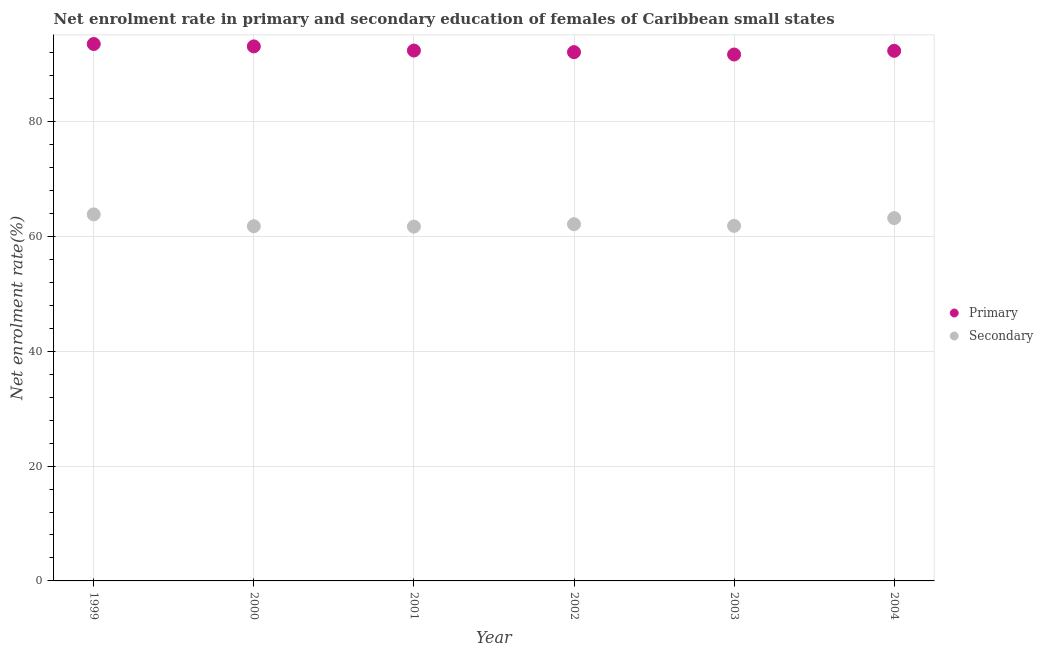What is the enrollment rate in primary education in 2001?
Make the answer very short. 92.38. Across all years, what is the maximum enrollment rate in primary education?
Your response must be concise. 93.51. Across all years, what is the minimum enrollment rate in secondary education?
Keep it short and to the point. 61.71. In which year was the enrollment rate in primary education maximum?
Ensure brevity in your answer.  1999. What is the total enrollment rate in secondary education in the graph?
Provide a succinct answer. 374.48. What is the difference between the enrollment rate in primary education in 2001 and that in 2004?
Give a very brief answer. 0.05. What is the difference between the enrollment rate in secondary education in 2001 and the enrollment rate in primary education in 2002?
Give a very brief answer. -30.38. What is the average enrollment rate in primary education per year?
Provide a succinct answer. 92.52. In the year 2003, what is the difference between the enrollment rate in secondary education and enrollment rate in primary education?
Offer a very short reply. -29.84. What is the ratio of the enrollment rate in secondary education in 2000 to that in 2004?
Keep it short and to the point. 0.98. Is the enrollment rate in secondary education in 1999 less than that in 2001?
Keep it short and to the point. No. Is the difference between the enrollment rate in secondary education in 1999 and 2003 greater than the difference between the enrollment rate in primary education in 1999 and 2003?
Make the answer very short. Yes. What is the difference between the highest and the second highest enrollment rate in primary education?
Your answer should be compact. 0.42. What is the difference between the highest and the lowest enrollment rate in secondary education?
Offer a terse response. 2.12. Is the sum of the enrollment rate in primary education in 1999 and 2001 greater than the maximum enrollment rate in secondary education across all years?
Ensure brevity in your answer.  Yes. Does the enrollment rate in secondary education monotonically increase over the years?
Your answer should be compact. No. What is the title of the graph?
Make the answer very short. Net enrolment rate in primary and secondary education of females of Caribbean small states. What is the label or title of the X-axis?
Ensure brevity in your answer.  Year. What is the label or title of the Y-axis?
Give a very brief answer. Net enrolment rate(%). What is the Net enrolment rate(%) of Primary in 1999?
Make the answer very short. 93.51. What is the Net enrolment rate(%) of Secondary in 1999?
Your answer should be compact. 63.84. What is the Net enrolment rate(%) of Primary in 2000?
Your response must be concise. 93.1. What is the Net enrolment rate(%) in Secondary in 2000?
Offer a very short reply. 61.78. What is the Net enrolment rate(%) in Primary in 2001?
Provide a short and direct response. 92.38. What is the Net enrolment rate(%) of Secondary in 2001?
Your answer should be very brief. 61.71. What is the Net enrolment rate(%) of Primary in 2002?
Make the answer very short. 92.09. What is the Net enrolment rate(%) in Secondary in 2002?
Your answer should be compact. 62.13. What is the Net enrolment rate(%) in Primary in 2003?
Your answer should be very brief. 91.69. What is the Net enrolment rate(%) in Secondary in 2003?
Your response must be concise. 61.84. What is the Net enrolment rate(%) in Primary in 2004?
Your answer should be compact. 92.33. What is the Net enrolment rate(%) in Secondary in 2004?
Offer a terse response. 63.19. Across all years, what is the maximum Net enrolment rate(%) in Primary?
Provide a succinct answer. 93.51. Across all years, what is the maximum Net enrolment rate(%) of Secondary?
Your response must be concise. 63.84. Across all years, what is the minimum Net enrolment rate(%) of Primary?
Your answer should be very brief. 91.69. Across all years, what is the minimum Net enrolment rate(%) of Secondary?
Ensure brevity in your answer.  61.71. What is the total Net enrolment rate(%) of Primary in the graph?
Your answer should be compact. 555.09. What is the total Net enrolment rate(%) in Secondary in the graph?
Make the answer very short. 374.48. What is the difference between the Net enrolment rate(%) of Primary in 1999 and that in 2000?
Make the answer very short. 0.42. What is the difference between the Net enrolment rate(%) in Secondary in 1999 and that in 2000?
Your response must be concise. 2.06. What is the difference between the Net enrolment rate(%) of Primary in 1999 and that in 2001?
Provide a succinct answer. 1.14. What is the difference between the Net enrolment rate(%) of Secondary in 1999 and that in 2001?
Provide a short and direct response. 2.12. What is the difference between the Net enrolment rate(%) of Primary in 1999 and that in 2002?
Your response must be concise. 1.42. What is the difference between the Net enrolment rate(%) in Secondary in 1999 and that in 2002?
Your response must be concise. 1.71. What is the difference between the Net enrolment rate(%) in Primary in 1999 and that in 2003?
Provide a succinct answer. 1.83. What is the difference between the Net enrolment rate(%) of Secondary in 1999 and that in 2003?
Your answer should be very brief. 1.99. What is the difference between the Net enrolment rate(%) in Primary in 1999 and that in 2004?
Offer a terse response. 1.19. What is the difference between the Net enrolment rate(%) of Secondary in 1999 and that in 2004?
Make the answer very short. 0.65. What is the difference between the Net enrolment rate(%) of Primary in 2000 and that in 2001?
Offer a very short reply. 0.72. What is the difference between the Net enrolment rate(%) in Secondary in 2000 and that in 2001?
Keep it short and to the point. 0.06. What is the difference between the Net enrolment rate(%) of Primary in 2000 and that in 2002?
Offer a terse response. 1. What is the difference between the Net enrolment rate(%) in Secondary in 2000 and that in 2002?
Provide a short and direct response. -0.35. What is the difference between the Net enrolment rate(%) in Primary in 2000 and that in 2003?
Ensure brevity in your answer.  1.41. What is the difference between the Net enrolment rate(%) in Secondary in 2000 and that in 2003?
Give a very brief answer. -0.07. What is the difference between the Net enrolment rate(%) in Primary in 2000 and that in 2004?
Offer a terse response. 0.77. What is the difference between the Net enrolment rate(%) of Secondary in 2000 and that in 2004?
Your response must be concise. -1.41. What is the difference between the Net enrolment rate(%) in Primary in 2001 and that in 2002?
Your response must be concise. 0.28. What is the difference between the Net enrolment rate(%) in Secondary in 2001 and that in 2002?
Your response must be concise. -0.42. What is the difference between the Net enrolment rate(%) of Primary in 2001 and that in 2003?
Your answer should be compact. 0.69. What is the difference between the Net enrolment rate(%) in Secondary in 2001 and that in 2003?
Ensure brevity in your answer.  -0.13. What is the difference between the Net enrolment rate(%) of Primary in 2001 and that in 2004?
Offer a terse response. 0.05. What is the difference between the Net enrolment rate(%) of Secondary in 2001 and that in 2004?
Make the answer very short. -1.48. What is the difference between the Net enrolment rate(%) in Primary in 2002 and that in 2003?
Keep it short and to the point. 0.41. What is the difference between the Net enrolment rate(%) in Secondary in 2002 and that in 2003?
Keep it short and to the point. 0.28. What is the difference between the Net enrolment rate(%) in Primary in 2002 and that in 2004?
Provide a succinct answer. -0.23. What is the difference between the Net enrolment rate(%) of Secondary in 2002 and that in 2004?
Your answer should be compact. -1.06. What is the difference between the Net enrolment rate(%) in Primary in 2003 and that in 2004?
Give a very brief answer. -0.64. What is the difference between the Net enrolment rate(%) of Secondary in 2003 and that in 2004?
Provide a short and direct response. -1.35. What is the difference between the Net enrolment rate(%) in Primary in 1999 and the Net enrolment rate(%) in Secondary in 2000?
Make the answer very short. 31.74. What is the difference between the Net enrolment rate(%) in Primary in 1999 and the Net enrolment rate(%) in Secondary in 2001?
Give a very brief answer. 31.8. What is the difference between the Net enrolment rate(%) in Primary in 1999 and the Net enrolment rate(%) in Secondary in 2002?
Your answer should be very brief. 31.39. What is the difference between the Net enrolment rate(%) of Primary in 1999 and the Net enrolment rate(%) of Secondary in 2003?
Your answer should be very brief. 31.67. What is the difference between the Net enrolment rate(%) of Primary in 1999 and the Net enrolment rate(%) of Secondary in 2004?
Offer a terse response. 30.32. What is the difference between the Net enrolment rate(%) in Primary in 2000 and the Net enrolment rate(%) in Secondary in 2001?
Offer a terse response. 31.39. What is the difference between the Net enrolment rate(%) of Primary in 2000 and the Net enrolment rate(%) of Secondary in 2002?
Provide a succinct answer. 30.97. What is the difference between the Net enrolment rate(%) of Primary in 2000 and the Net enrolment rate(%) of Secondary in 2003?
Keep it short and to the point. 31.25. What is the difference between the Net enrolment rate(%) in Primary in 2000 and the Net enrolment rate(%) in Secondary in 2004?
Make the answer very short. 29.91. What is the difference between the Net enrolment rate(%) of Primary in 2001 and the Net enrolment rate(%) of Secondary in 2002?
Your answer should be very brief. 30.25. What is the difference between the Net enrolment rate(%) in Primary in 2001 and the Net enrolment rate(%) in Secondary in 2003?
Offer a terse response. 30.53. What is the difference between the Net enrolment rate(%) of Primary in 2001 and the Net enrolment rate(%) of Secondary in 2004?
Give a very brief answer. 29.19. What is the difference between the Net enrolment rate(%) in Primary in 2002 and the Net enrolment rate(%) in Secondary in 2003?
Your answer should be compact. 30.25. What is the difference between the Net enrolment rate(%) in Primary in 2002 and the Net enrolment rate(%) in Secondary in 2004?
Your answer should be very brief. 28.9. What is the difference between the Net enrolment rate(%) of Primary in 2003 and the Net enrolment rate(%) of Secondary in 2004?
Ensure brevity in your answer.  28.5. What is the average Net enrolment rate(%) of Primary per year?
Offer a very short reply. 92.52. What is the average Net enrolment rate(%) of Secondary per year?
Offer a terse response. 62.41. In the year 1999, what is the difference between the Net enrolment rate(%) in Primary and Net enrolment rate(%) in Secondary?
Offer a terse response. 29.68. In the year 2000, what is the difference between the Net enrolment rate(%) in Primary and Net enrolment rate(%) in Secondary?
Offer a very short reply. 31.32. In the year 2001, what is the difference between the Net enrolment rate(%) in Primary and Net enrolment rate(%) in Secondary?
Your response must be concise. 30.66. In the year 2002, what is the difference between the Net enrolment rate(%) of Primary and Net enrolment rate(%) of Secondary?
Offer a very short reply. 29.97. In the year 2003, what is the difference between the Net enrolment rate(%) of Primary and Net enrolment rate(%) of Secondary?
Provide a succinct answer. 29.84. In the year 2004, what is the difference between the Net enrolment rate(%) of Primary and Net enrolment rate(%) of Secondary?
Offer a very short reply. 29.14. What is the ratio of the Net enrolment rate(%) in Primary in 1999 to that in 2000?
Make the answer very short. 1. What is the ratio of the Net enrolment rate(%) of Secondary in 1999 to that in 2000?
Your answer should be compact. 1.03. What is the ratio of the Net enrolment rate(%) in Primary in 1999 to that in 2001?
Your response must be concise. 1.01. What is the ratio of the Net enrolment rate(%) in Secondary in 1999 to that in 2001?
Provide a succinct answer. 1.03. What is the ratio of the Net enrolment rate(%) of Primary in 1999 to that in 2002?
Give a very brief answer. 1.02. What is the ratio of the Net enrolment rate(%) in Secondary in 1999 to that in 2002?
Your response must be concise. 1.03. What is the ratio of the Net enrolment rate(%) in Primary in 1999 to that in 2003?
Provide a succinct answer. 1.02. What is the ratio of the Net enrolment rate(%) in Secondary in 1999 to that in 2003?
Keep it short and to the point. 1.03. What is the ratio of the Net enrolment rate(%) in Primary in 1999 to that in 2004?
Offer a very short reply. 1.01. What is the ratio of the Net enrolment rate(%) of Secondary in 1999 to that in 2004?
Provide a short and direct response. 1.01. What is the ratio of the Net enrolment rate(%) of Primary in 2000 to that in 2002?
Ensure brevity in your answer.  1.01. What is the ratio of the Net enrolment rate(%) in Secondary in 2000 to that in 2002?
Ensure brevity in your answer.  0.99. What is the ratio of the Net enrolment rate(%) of Primary in 2000 to that in 2003?
Keep it short and to the point. 1.02. What is the ratio of the Net enrolment rate(%) in Primary in 2000 to that in 2004?
Provide a short and direct response. 1.01. What is the ratio of the Net enrolment rate(%) of Secondary in 2000 to that in 2004?
Offer a terse response. 0.98. What is the ratio of the Net enrolment rate(%) in Primary in 2001 to that in 2002?
Keep it short and to the point. 1. What is the ratio of the Net enrolment rate(%) of Primary in 2001 to that in 2003?
Ensure brevity in your answer.  1.01. What is the ratio of the Net enrolment rate(%) in Primary in 2001 to that in 2004?
Offer a very short reply. 1. What is the ratio of the Net enrolment rate(%) of Secondary in 2001 to that in 2004?
Keep it short and to the point. 0.98. What is the ratio of the Net enrolment rate(%) of Secondary in 2002 to that in 2004?
Your answer should be compact. 0.98. What is the ratio of the Net enrolment rate(%) in Primary in 2003 to that in 2004?
Your answer should be very brief. 0.99. What is the ratio of the Net enrolment rate(%) of Secondary in 2003 to that in 2004?
Your answer should be very brief. 0.98. What is the difference between the highest and the second highest Net enrolment rate(%) in Primary?
Offer a very short reply. 0.42. What is the difference between the highest and the second highest Net enrolment rate(%) in Secondary?
Make the answer very short. 0.65. What is the difference between the highest and the lowest Net enrolment rate(%) in Primary?
Provide a succinct answer. 1.83. What is the difference between the highest and the lowest Net enrolment rate(%) of Secondary?
Give a very brief answer. 2.12. 